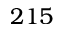Convert formula to latex. <formula><loc_0><loc_0><loc_500><loc_500>2 1 5</formula> 